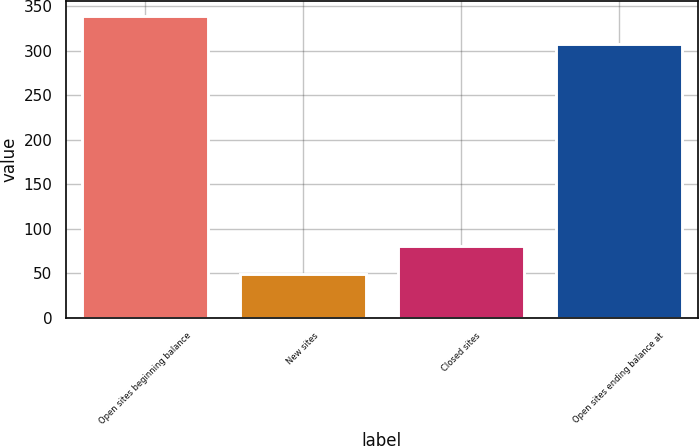Convert chart. <chart><loc_0><loc_0><loc_500><loc_500><bar_chart><fcel>Open sites beginning balance<fcel>New sites<fcel>Closed sites<fcel>Open sites ending balance at<nl><fcel>339<fcel>49<fcel>81<fcel>307<nl></chart> 